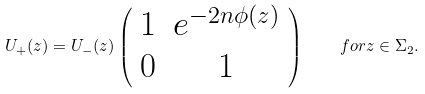Convert formula to latex. <formula><loc_0><loc_0><loc_500><loc_500>U _ { + } ( z ) = U _ { - } ( z ) \left ( \begin{array} { c c } 1 & e ^ { - 2 n \phi ( z ) } \\ 0 & 1 \end{array} \right ) \quad f o r z \in \Sigma _ { 2 } .</formula> 